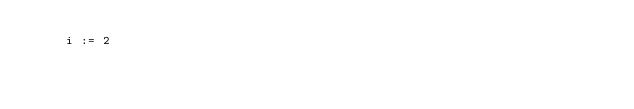<code> <loc_0><loc_0><loc_500><loc_500><_SQL_>    i := 2
</code> 